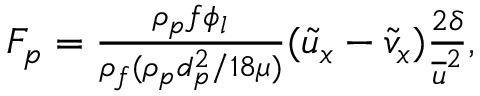<formula> <loc_0><loc_0><loc_500><loc_500>\begin{array} { r } { F _ { p } = \frac { \rho _ { p } f \phi _ { l } } { \rho _ { f } ( \rho _ { p } d _ { p } ^ { 2 } / 1 8 \mu ) } ( \widetilde { u } _ { x } - \widetilde { v } _ { x } ) \frac { 2 \delta } { \overline { u } ^ { 2 } } , } \end{array}</formula> 